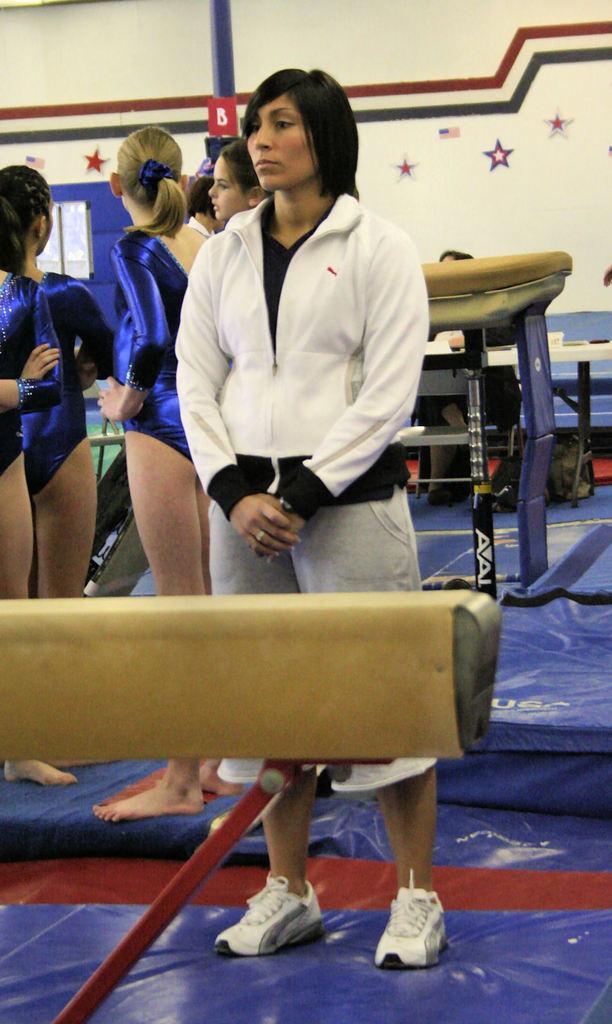Can you describe this image briefly? In the middle of this image, there is a woman in a white color jacket standing. In front of her, there is an object. In the background, there are other women, a pole, there are stickers attached to a white wall and other objects. 